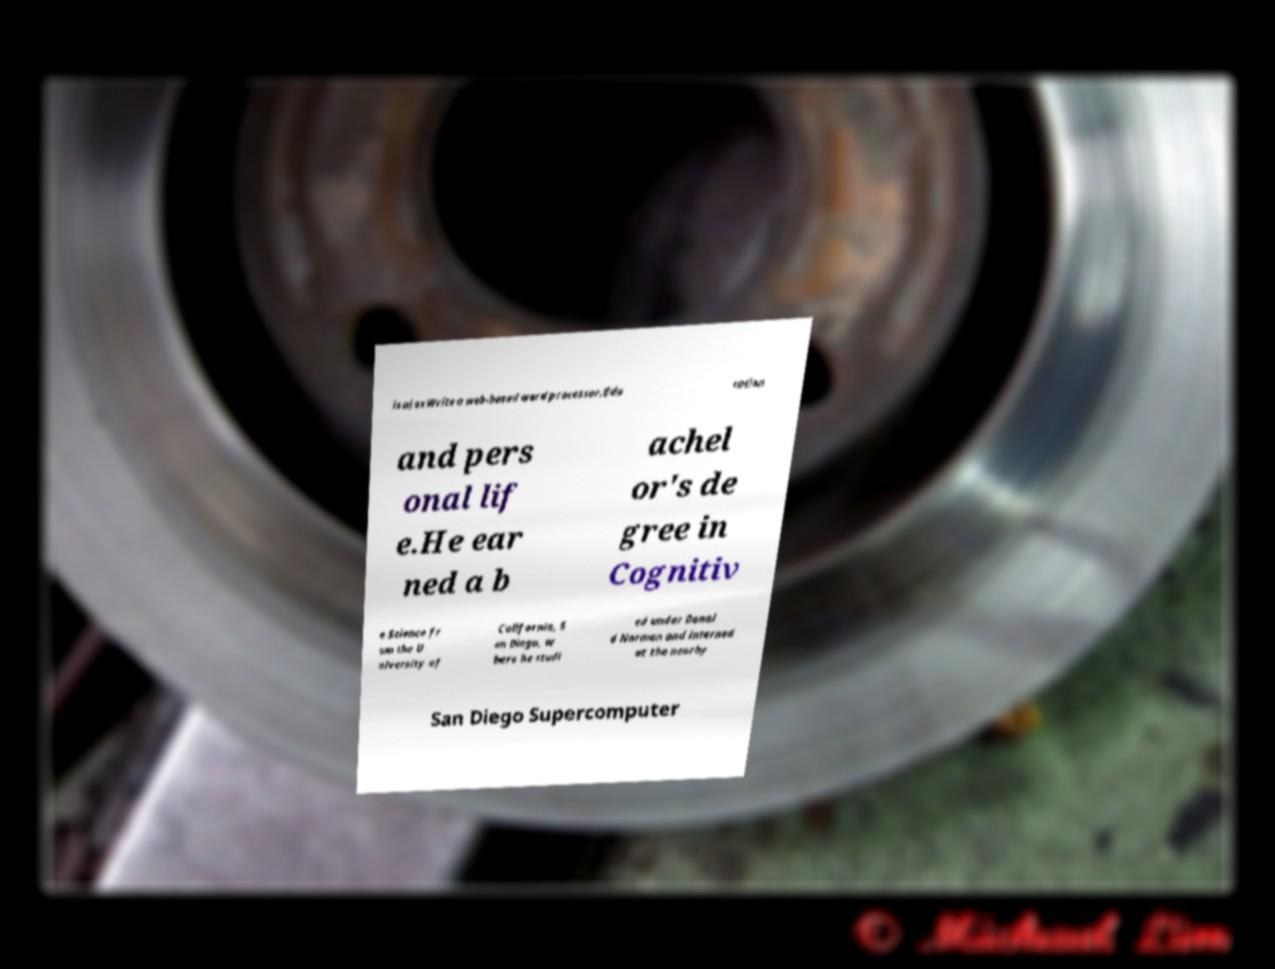For documentation purposes, I need the text within this image transcribed. Could you provide that? is ajaxWrite a web-based word processor.Edu cation and pers onal lif e.He ear ned a b achel or's de gree in Cognitiv e Science fr om the U niversity of California, S an Diego, w here he studi ed under Donal d Norman and interned at the nearby San Diego Supercomputer 